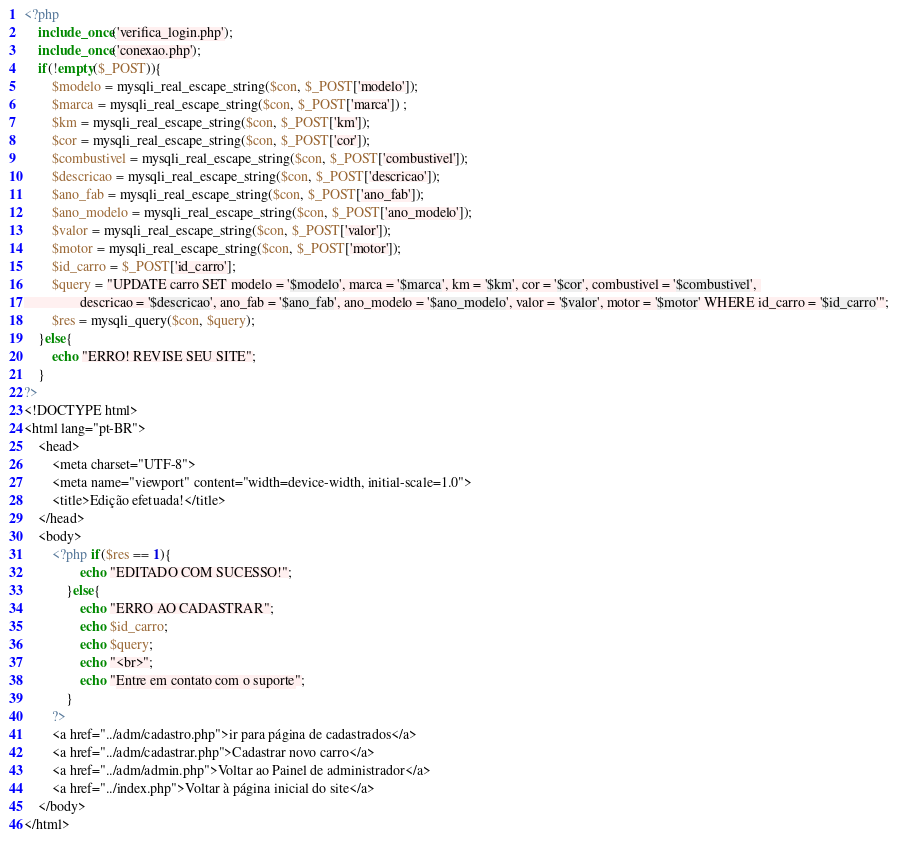<code> <loc_0><loc_0><loc_500><loc_500><_PHP_><?php 
    include_once('verifica_login.php');
    include_once('conexao.php');
    if(!empty($_POST)){
        $modelo = mysqli_real_escape_string($con, $_POST['modelo']);
        $marca = mysqli_real_escape_string($con, $_POST['marca']) ;
        $km = mysqli_real_escape_string($con, $_POST['km']);
        $cor = mysqli_real_escape_string($con, $_POST['cor']);
        $combustivel = mysqli_real_escape_string($con, $_POST['combustivel']);
        $descricao = mysqli_real_escape_string($con, $_POST['descricao']);
        $ano_fab = mysqli_real_escape_string($con, $_POST['ano_fab']);
        $ano_modelo = mysqli_real_escape_string($con, $_POST['ano_modelo']);
        $valor = mysqli_real_escape_string($con, $_POST['valor']);
        $motor = mysqli_real_escape_string($con, $_POST['motor']);
        $id_carro = $_POST['id_carro'];
        $query = "UPDATE carro SET modelo = '$modelo', marca = '$marca', km = '$km', cor = '$cor', combustivel = '$combustivel', 
                descricao = '$descricao', ano_fab = '$ano_fab', ano_modelo = '$ano_modelo', valor = '$valor', motor = '$motor' WHERE id_carro = '$id_carro'";
        $res = mysqli_query($con, $query);
    }else{
        echo "ERRO! REVISE SEU SITE";
    }
?>
<!DOCTYPE html>
<html lang="pt-BR">
    <head>
        <meta charset="UTF-8">
        <meta name="viewport" content="width=device-width, initial-scale=1.0">
        <title>Edição efetuada!</title>
    </head>
    <body>
        <?php if($res == 1){
                echo "EDITADO COM SUCESSO!";
            }else{
                echo "ERRO AO CADASTRAR";
                echo $id_carro;
                echo $query;
                echo "<br>";
                echo "Entre em contato com o suporte";
            }
        ?>
        <a href="../adm/cadastro.php">ir para página de cadastrados</a>
        <a href="../adm/cadastrar.php">Cadastrar novo carro</a>
        <a href="../adm/admin.php">Voltar ao Painel de administrador</a>
        <a href="../index.php">Voltar à página inicial do site</a>
    </body>
</html></code> 